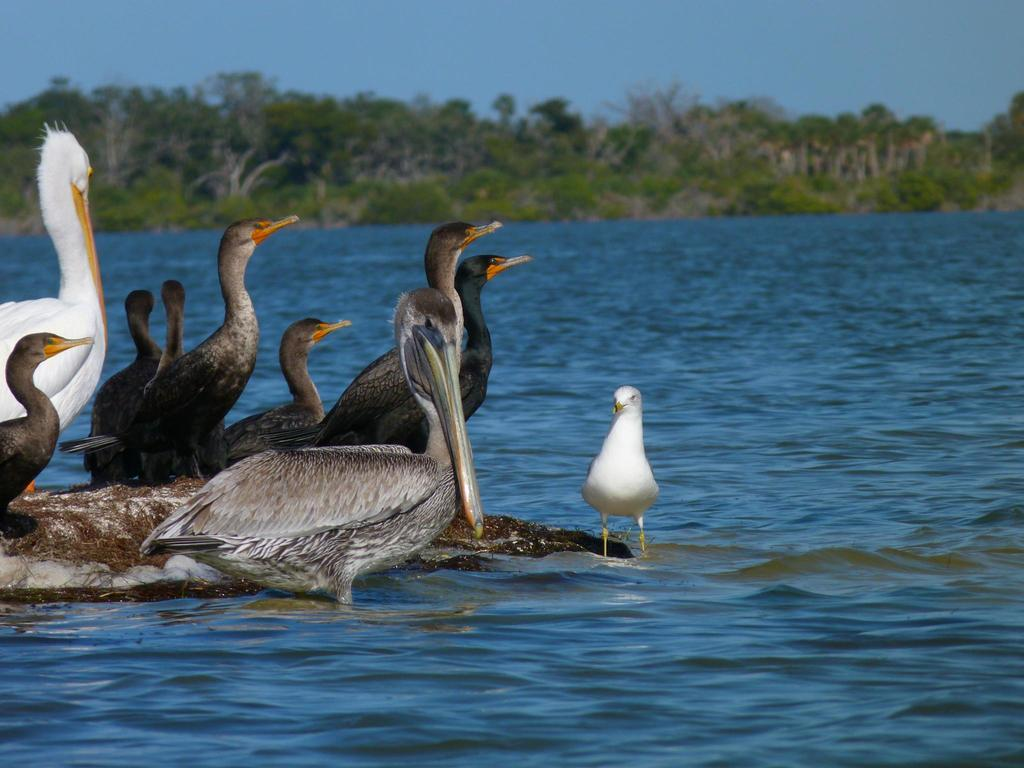What type of animals can be seen in the image? There are many ducks of different colors in the image. What is the primary element in which the ducks are situated? There is water visible in the image, and the ducks are in the water. What can be seen in the background of the image? There are trees and plants in the image, as well as the sky. How many zebras can be seen grazing in the image? There are no zebras present in the image; it features many ducks of different colors. Can you tell me how many rabbits are hiding among the plants in the image? There are no rabbits visible in the image; it features ducks, trees, plants, and the sky. 